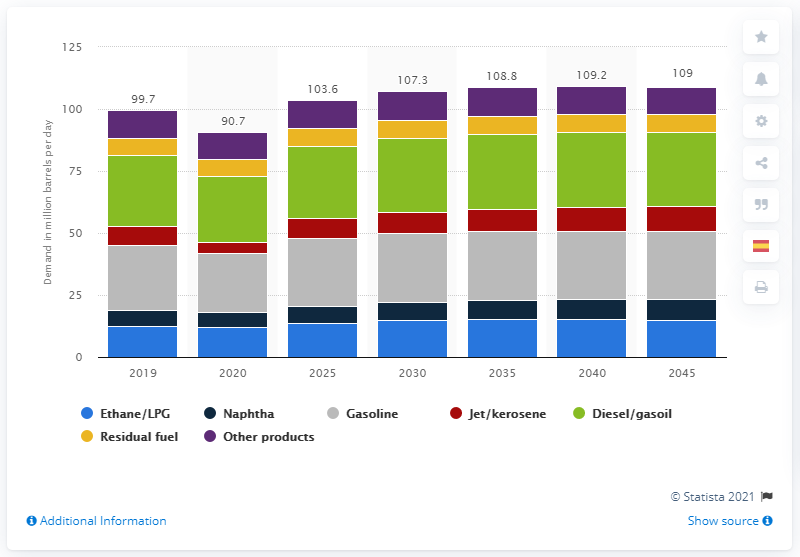Identify some key points in this picture. The COVID-19 pandemic had a significant impact on the consumption of liquid fuels in early 2020, with a recorded consumption of 29.8%. By 2045, it is projected that a daily average of 27.6 barrels of gasoline will be consumed. It is expected that the daily demand for diesel and gasoil will reach approximately 29.8 units in 2045. 